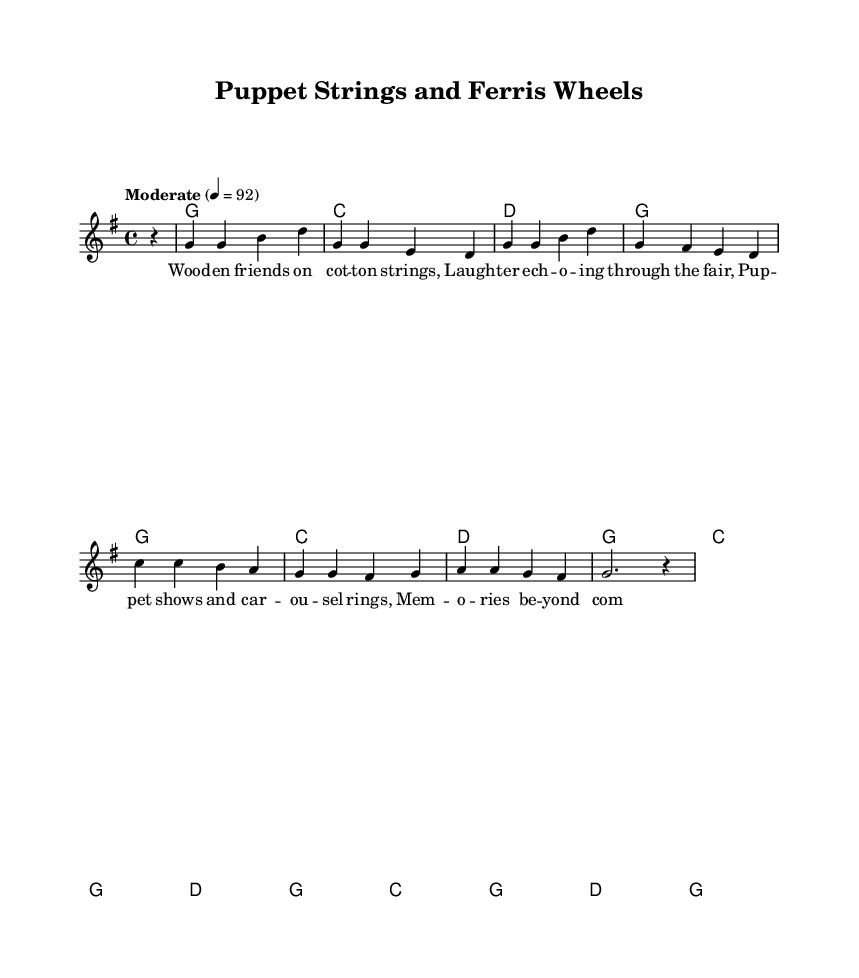What is the key signature of this music? The key signature is G major, which has one sharp (F#). This is identified by looking at the beginning of the staff and recognizing the sharp symbol before the note F.
Answer: G major What is the time signature of this music? The time signature is 4/4, which means there are four beats in each measure and the quarter note gets one beat. This can be seen directly in the music notation at the start of the piece.
Answer: 4/4 What is the tempo marking of this music? The tempo marking is "Moderate" with a metronome marking of 92 beats per minute. This indicates the speed at which the piece should be played, usually found above the staff.
Answer: Moderate, 92 How many measures are in the melody part? There are 8 measures in the melody part, which are counted by observing each group of musical notes separated by vertical lines (bar lines).
Answer: 8 Which chords are used in the verse? The chords used in the verse are G, C, and D. This can be deduced from the chord names placed above the melody throughout the verse section.
Answer: G, C, D What is the first lyric of the chorus? The first lyric of the chorus is "Oh," which is indicated by the lyrics aligned below the corresponding notes in the chorus section.
Answer: Oh What theme is reflected in this song? The theme reflected in this song is nostalgia for childhood experiences, such as puppet shows and county fairs, as indicated by the lyrics discussing memories of joy during summer.
Answer: Nostalgia 